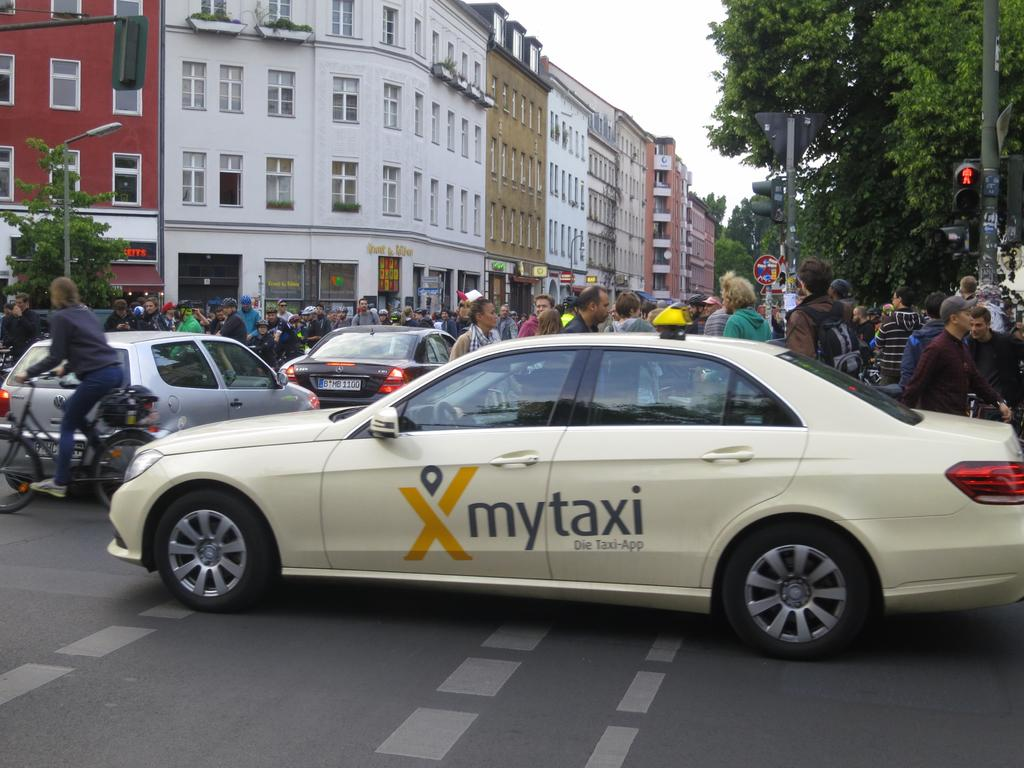Provide a one-sentence caption for the provided image. A car that says mytaxi is trying to get through a street filled with people. 